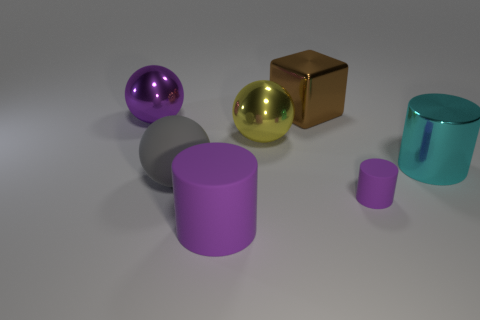Is there anything else that has the same size as the yellow shiny object?
Offer a terse response. Yes. Do the metallic object on the right side of the small object and the rubber thing right of the brown metal block have the same shape?
Offer a very short reply. Yes. What is the shape of the purple metallic thing that is the same size as the rubber ball?
Give a very brief answer. Sphere. Are there the same number of gray matte things that are in front of the brown thing and metallic balls left of the purple metal thing?
Make the answer very short. No. Is there anything else that has the same shape as the big cyan metal thing?
Ensure brevity in your answer.  Yes. Is the big cylinder behind the big purple matte cylinder made of the same material as the big yellow sphere?
Keep it short and to the point. Yes. There is a gray object that is the same size as the brown metallic block; what material is it?
Your response must be concise. Rubber. How many other things are there of the same material as the brown object?
Provide a short and direct response. 3. There is a rubber ball; is it the same size as the brown cube that is behind the cyan metallic thing?
Provide a short and direct response. Yes. Is the number of big cylinders that are behind the large purple shiny ball less than the number of large cyan objects that are on the right side of the cyan metal thing?
Ensure brevity in your answer.  No. 